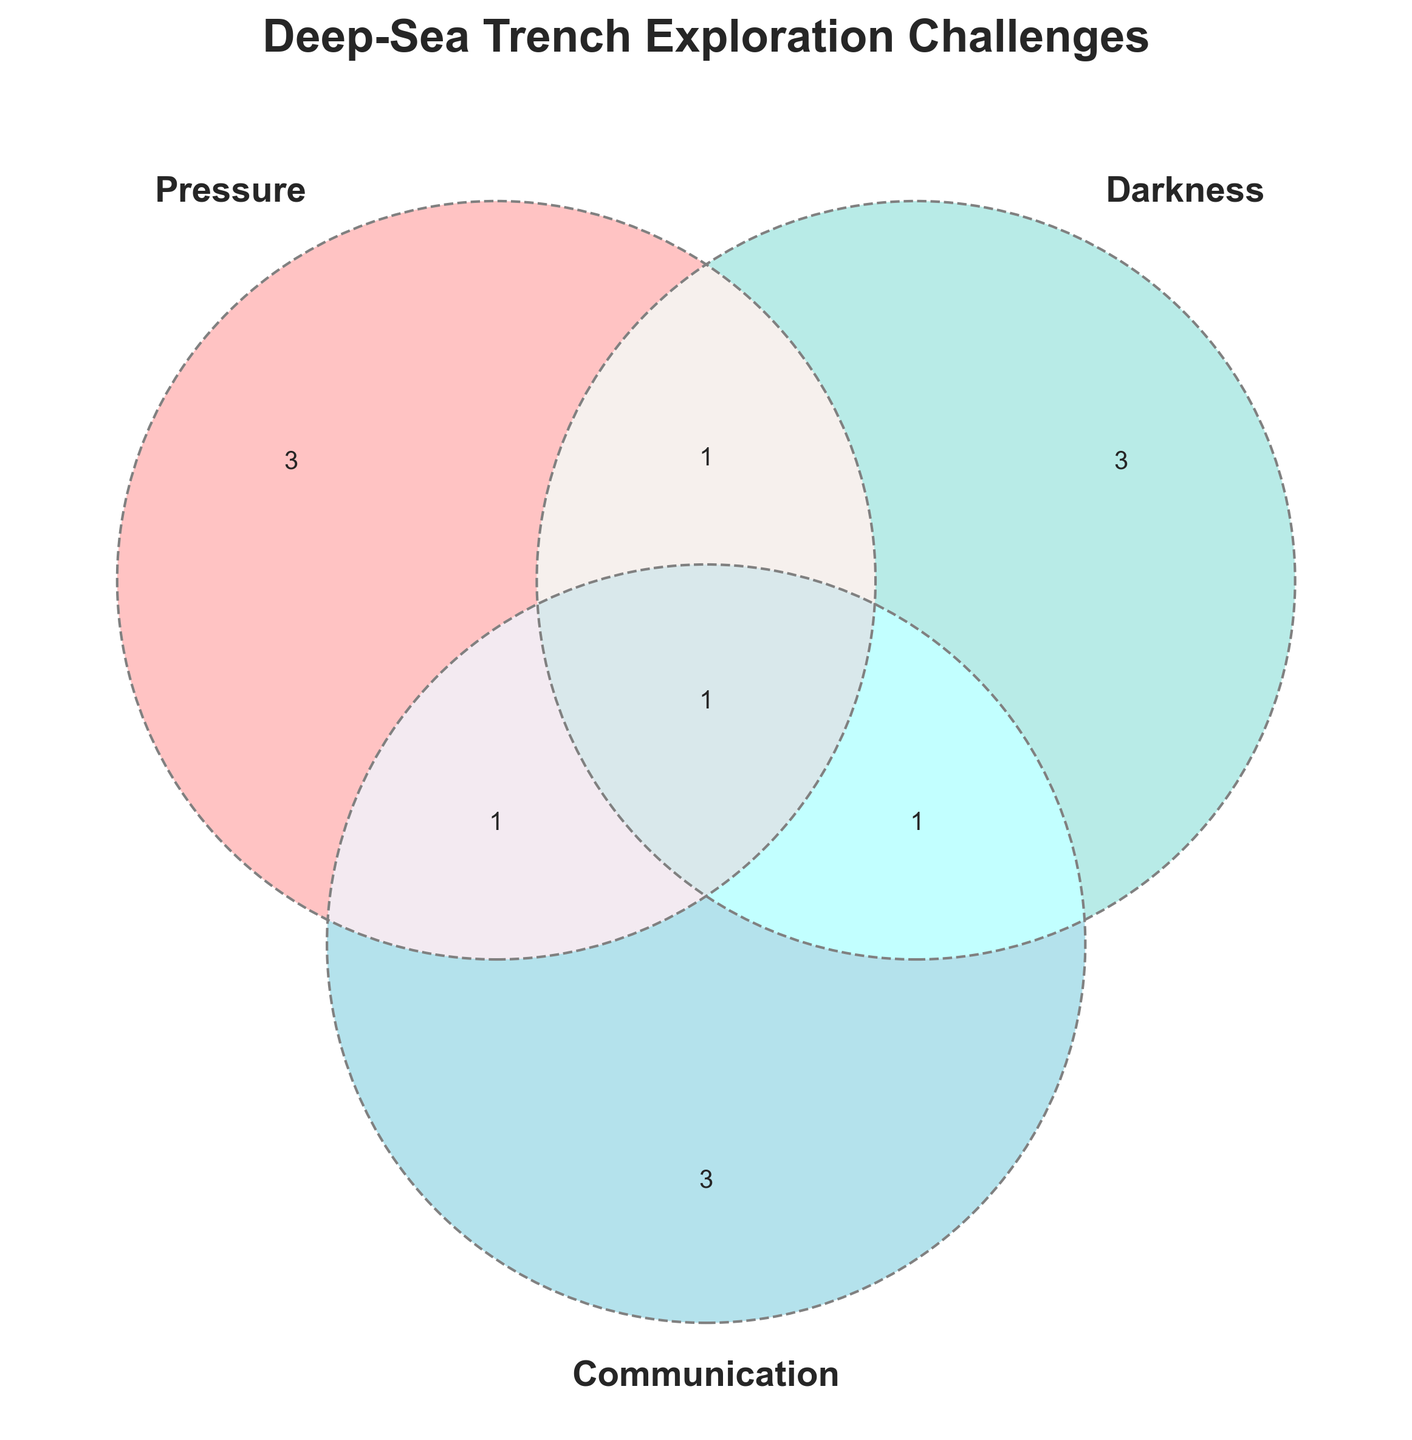What is the title of the Venn diagram? The title is displayed at the top of the figure, written in large, bold, and uppercase letters.
Answer: Deep-Sea Trench Exploration Challenges How many challenges are unique to 'Pressure'? We look at the segment only for 'Pressure,' which contains "Structural integrity," "Equipment failure," and "Buoyancy control." There are 3 unique challenges.
Answer: 3 Does 'Darkness' share any challenges with 'Communication' that 'Pressure' does not? The 'Darkness' and 'Communication' section contains "Image quality degradation" as a shared challenge. It does not overlap with 'Pressure.'
Answer: Yes Which challenge is found in all three categories? The intersection of all three categories, 'Pressure,' 'Darkness,' and 'Communication,' contains only one challenge, "ROV navigation."
Answer: ROV navigation What are the shared challenges between 'Pressure' and 'Communication'? The shared region between 'Pressure' and 'Communication' but excluding 'Darkness' has "Data transmission delays."
Answer: Data transmission delays How many total challenges are associated with 'Communication'? Count the 'Communication'-related challenges: "Signal attenuation," "Bandwidth limitations," "Tether management," "Data transmission delays," "Image quality degradation," and "ROV navigation." This totals 6.
Answer: 6 Compare the number of unique challenges in 'Pressure' and 'Darkness'. Which category has more? 'Pressure' has 3 unique challenges ("Structural integrity," "Equipment failure," "Buoyancy control"), while 'Darkness' has 3 ("Low visibility," "Limited camera range," "Specialized lighting"). The number is the same for both categories.
Answer: Equal Which challenge is associated with 'Pressure' and 'Darkness' but not 'Communication'? The intersection of 'Pressure' and 'Darkness,' excluding 'Communication,' contains "Sensor calibration."
Answer: Sensor calibration List the challenges that are shared by at least two categories. The shared challenges are in the overlapping sections: "Sensor calibration," "Data transmission delays," "Image quality degradation," and "ROV navigation."
Answer: Sensor calibration, Data transmission delays, Image quality degradation, ROV navigation 